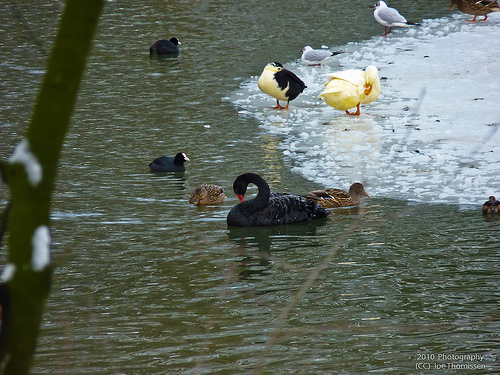<image>
Can you confirm if the duck is above the water? No. The duck is not positioned above the water. The vertical arrangement shows a different relationship. Where is the ice in relation to the plant? Is it behind the plant? Yes. From this viewpoint, the ice is positioned behind the plant, with the plant partially or fully occluding the ice. Is there a duck on the water? Yes. Looking at the image, I can see the duck is positioned on top of the water, with the water providing support. 